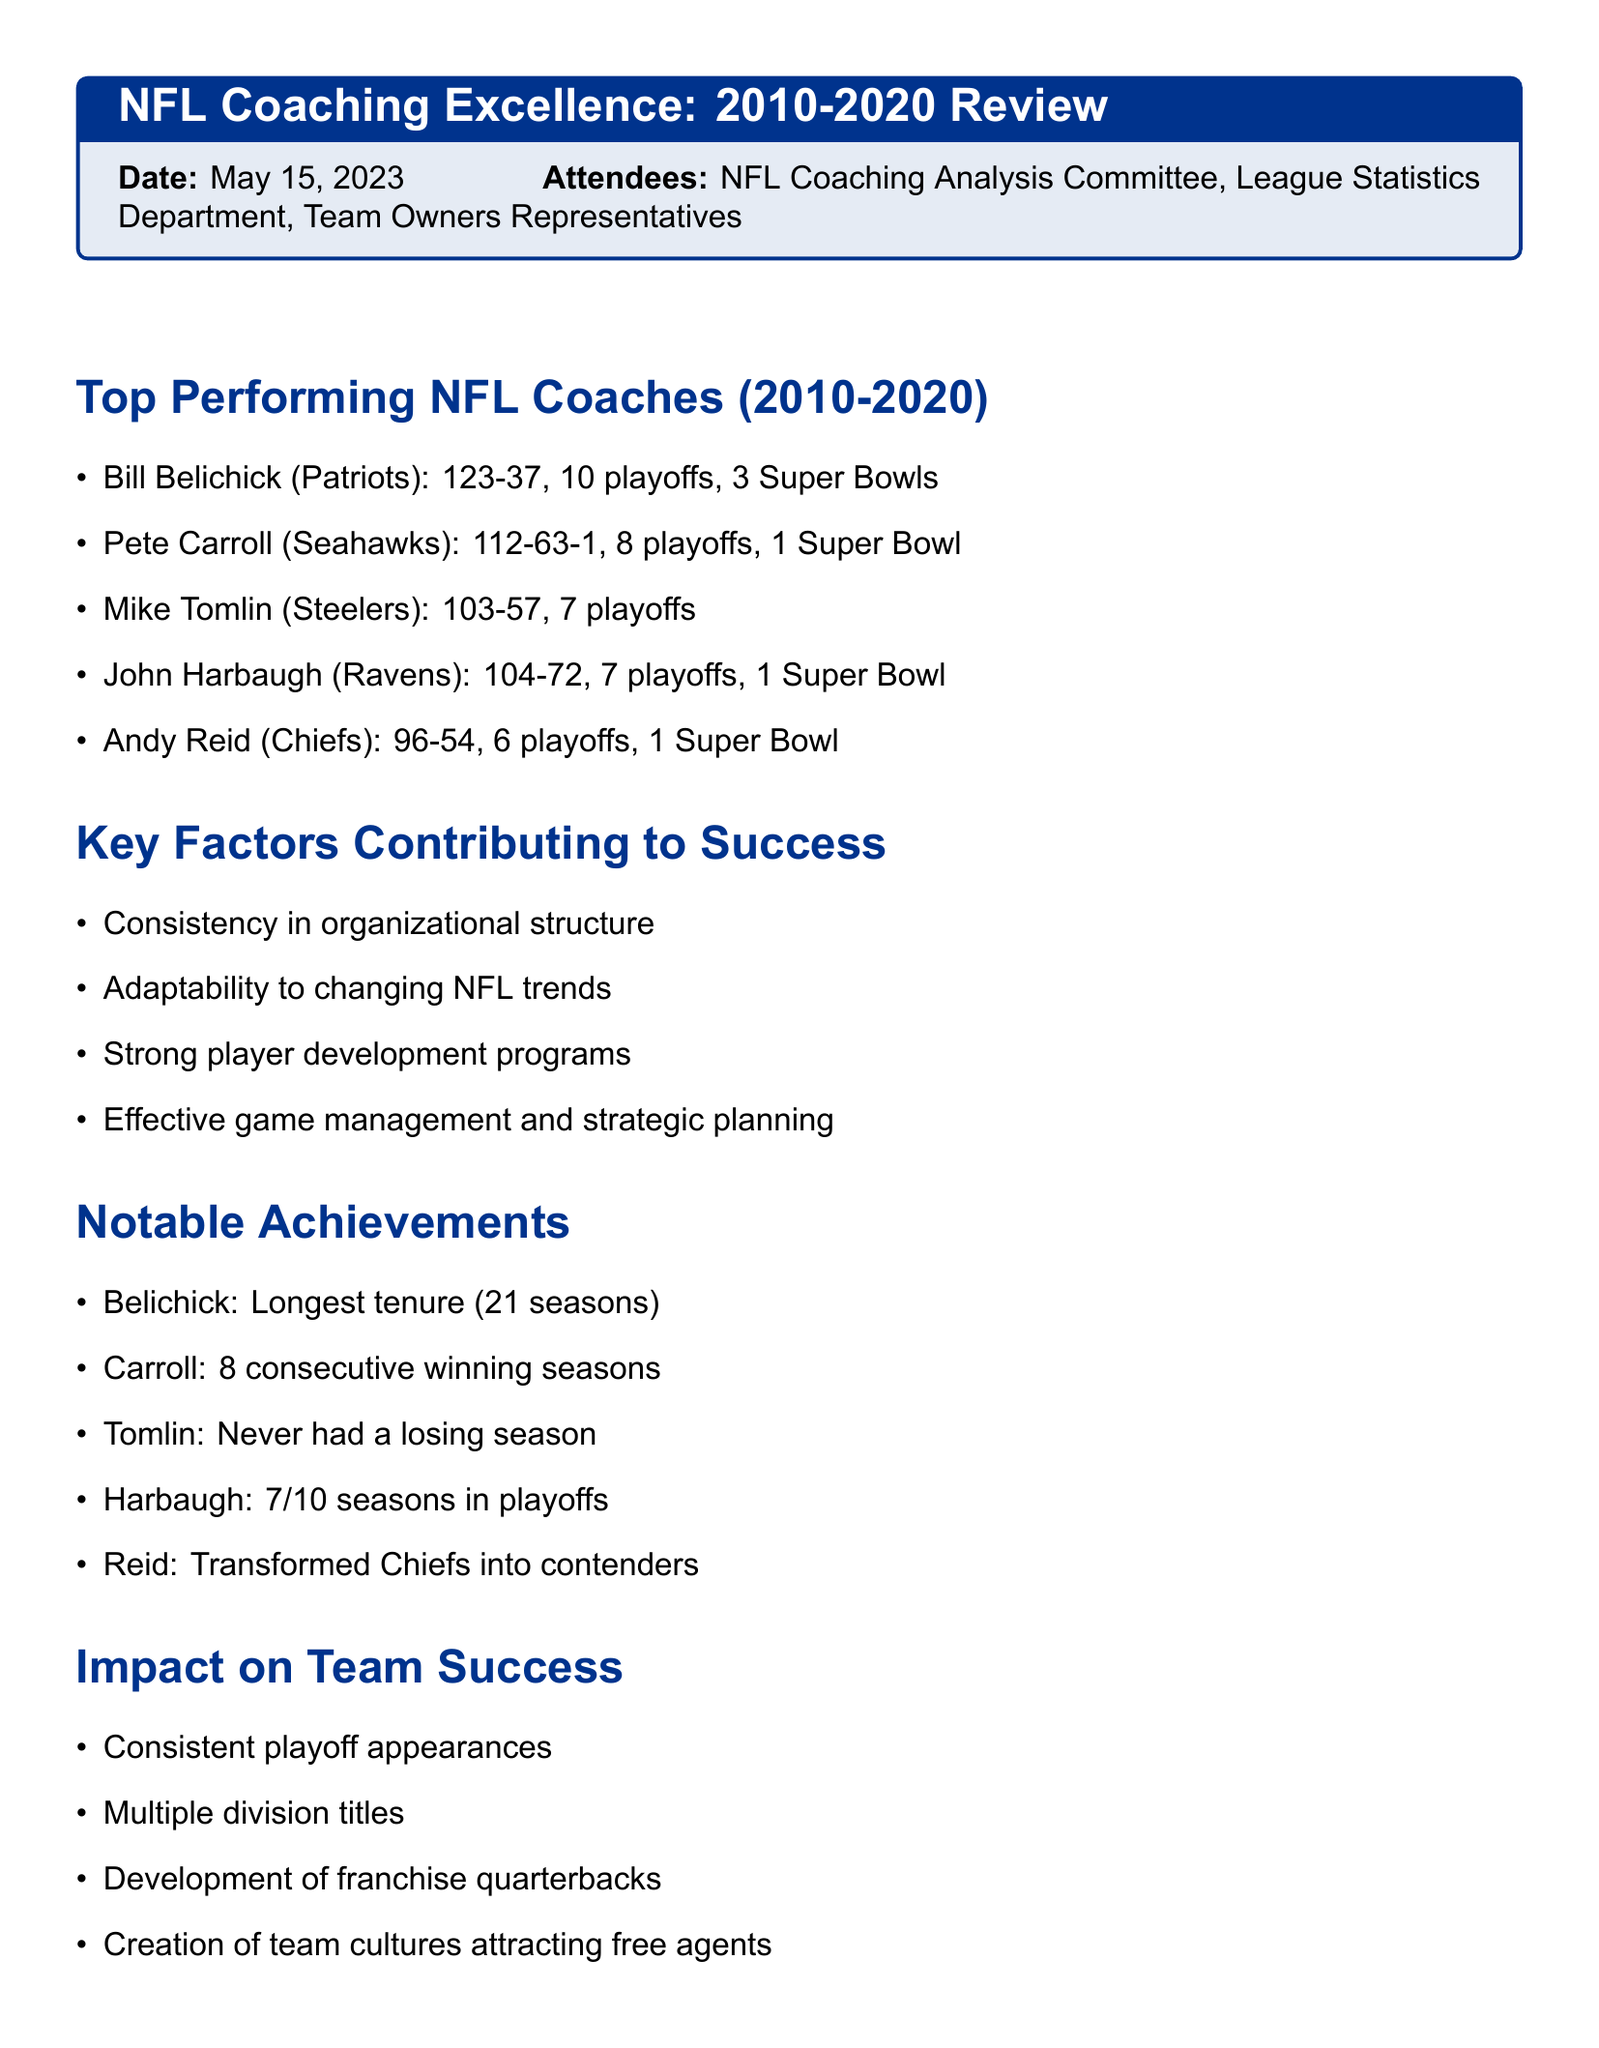What is the title of the meeting? The title of the meeting is stated clearly at the beginning of the document.
Answer: NFL Coaching Excellence: 2010-2020 Review When was the meeting held? The date is explicitly mentioned in the document.
Answer: May 15, 2023 Who is the top coach listed in the document? The document provides a list of top coaches with Bill Belichick mentioned first.
Answer: Bill Belichick How many Super Bowl wins does Pete Carroll have? The number of Super Bowl wins for each coach is included in their respective records.
Answer: 1 Super Bowl What is Mike Tomlin's win-loss record? The document specifies Mike Tomlin's record directly.
Answer: 103-57 Which coach has the longest tenure with a single team? Notable achievements highlight significant records, including tenure lengths.
Answer: Bill Belichick How many playoff appearances did Andy Reid have? The information about playoff appearances per coach is presented.
Answer: 6 playoff appearances What is mentioned as a key factor contributing to success? Key factors are listed, and one can be chosen based on the content provided.
Answer: Consistency in organizational structure What is one of the action items proposed? The action items section describes tasks that need to be tackled, one of which can be selected.
Answer: Conduct in-depth analysis of coaching strategies 